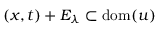Convert formula to latex. <formula><loc_0><loc_0><loc_500><loc_500>( x , t ) + E _ { \lambda } \subset d o m ( u )</formula> 